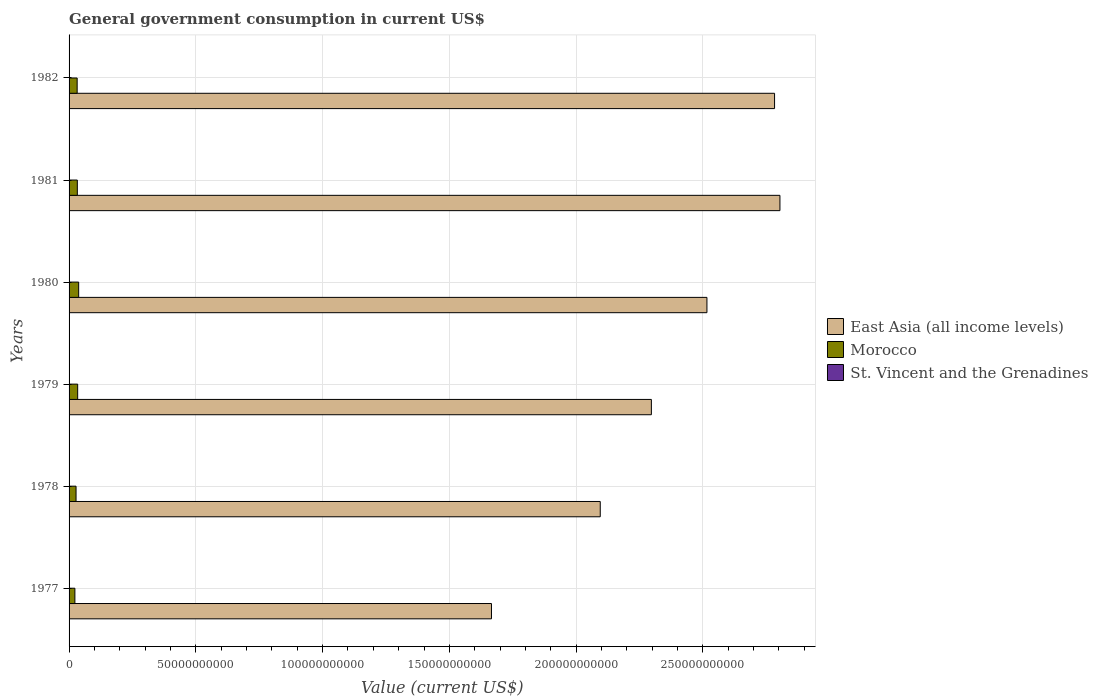How many groups of bars are there?
Offer a terse response. 6. How many bars are there on the 3rd tick from the bottom?
Offer a very short reply. 3. What is the label of the 3rd group of bars from the top?
Offer a very short reply. 1980. What is the government conusmption in East Asia (all income levels) in 1977?
Offer a terse response. 1.67e+11. Across all years, what is the maximum government conusmption in East Asia (all income levels)?
Make the answer very short. 2.80e+11. Across all years, what is the minimum government conusmption in St. Vincent and the Grenadines?
Make the answer very short. 8.13e+06. What is the total government conusmption in Morocco in the graph?
Keep it short and to the point. 1.87e+1. What is the difference between the government conusmption in St. Vincent and the Grenadines in 1977 and that in 1978?
Your response must be concise. -2.10e+06. What is the difference between the government conusmption in St. Vincent and the Grenadines in 1981 and the government conusmption in Morocco in 1979?
Provide a succinct answer. -3.38e+09. What is the average government conusmption in East Asia (all income levels) per year?
Your response must be concise. 2.36e+11. In the year 1980, what is the difference between the government conusmption in East Asia (all income levels) and government conusmption in St. Vincent and the Grenadines?
Provide a succinct answer. 2.52e+11. What is the ratio of the government conusmption in Morocco in 1978 to that in 1981?
Provide a short and direct response. 0.85. What is the difference between the highest and the second highest government conusmption in Morocco?
Your answer should be very brief. 3.96e+08. What is the difference between the highest and the lowest government conusmption in Morocco?
Your answer should be compact. 1.50e+09. In how many years, is the government conusmption in East Asia (all income levels) greater than the average government conusmption in East Asia (all income levels) taken over all years?
Make the answer very short. 3. What does the 1st bar from the top in 1981 represents?
Keep it short and to the point. St. Vincent and the Grenadines. What does the 1st bar from the bottom in 1977 represents?
Offer a terse response. East Asia (all income levels). Is it the case that in every year, the sum of the government conusmption in Morocco and government conusmption in St. Vincent and the Grenadines is greater than the government conusmption in East Asia (all income levels)?
Provide a succinct answer. No. How many bars are there?
Offer a terse response. 18. Are all the bars in the graph horizontal?
Give a very brief answer. Yes. How many years are there in the graph?
Ensure brevity in your answer.  6. Does the graph contain any zero values?
Your response must be concise. No. How many legend labels are there?
Make the answer very short. 3. How are the legend labels stacked?
Keep it short and to the point. Vertical. What is the title of the graph?
Ensure brevity in your answer.  General government consumption in current US$. Does "Zimbabwe" appear as one of the legend labels in the graph?
Your response must be concise. No. What is the label or title of the X-axis?
Make the answer very short. Value (current US$). What is the Value (current US$) of East Asia (all income levels) in 1977?
Provide a succinct answer. 1.67e+11. What is the Value (current US$) in Morocco in 1977?
Provide a short and direct response. 2.29e+09. What is the Value (current US$) of St. Vincent and the Grenadines in 1977?
Your response must be concise. 8.13e+06. What is the Value (current US$) in East Asia (all income levels) in 1978?
Your answer should be very brief. 2.10e+11. What is the Value (current US$) of Morocco in 1978?
Your response must be concise. 2.75e+09. What is the Value (current US$) in St. Vincent and the Grenadines in 1978?
Ensure brevity in your answer.  1.02e+07. What is the Value (current US$) of East Asia (all income levels) in 1979?
Make the answer very short. 2.30e+11. What is the Value (current US$) in Morocco in 1979?
Provide a short and direct response. 3.39e+09. What is the Value (current US$) of St. Vincent and the Grenadines in 1979?
Offer a very short reply. 1.26e+07. What is the Value (current US$) in East Asia (all income levels) in 1980?
Offer a very short reply. 2.52e+11. What is the Value (current US$) in Morocco in 1980?
Your answer should be very brief. 3.79e+09. What is the Value (current US$) of St. Vincent and the Grenadines in 1980?
Make the answer very short. 1.39e+07. What is the Value (current US$) in East Asia (all income levels) in 1981?
Your answer should be compact. 2.80e+11. What is the Value (current US$) in Morocco in 1981?
Ensure brevity in your answer.  3.26e+09. What is the Value (current US$) in St. Vincent and the Grenadines in 1981?
Provide a short and direct response. 1.73e+07. What is the Value (current US$) of East Asia (all income levels) in 1982?
Your response must be concise. 2.78e+11. What is the Value (current US$) in Morocco in 1982?
Your answer should be compact. 3.19e+09. What is the Value (current US$) in St. Vincent and the Grenadines in 1982?
Provide a short and direct response. 2.00e+07. Across all years, what is the maximum Value (current US$) in East Asia (all income levels)?
Give a very brief answer. 2.80e+11. Across all years, what is the maximum Value (current US$) in Morocco?
Provide a succinct answer. 3.79e+09. Across all years, what is the maximum Value (current US$) of St. Vincent and the Grenadines?
Ensure brevity in your answer.  2.00e+07. Across all years, what is the minimum Value (current US$) of East Asia (all income levels)?
Your answer should be very brief. 1.67e+11. Across all years, what is the minimum Value (current US$) in Morocco?
Keep it short and to the point. 2.29e+09. Across all years, what is the minimum Value (current US$) in St. Vincent and the Grenadines?
Ensure brevity in your answer.  8.13e+06. What is the total Value (current US$) in East Asia (all income levels) in the graph?
Give a very brief answer. 1.42e+12. What is the total Value (current US$) in Morocco in the graph?
Your response must be concise. 1.87e+1. What is the total Value (current US$) of St. Vincent and the Grenadines in the graph?
Your response must be concise. 8.22e+07. What is the difference between the Value (current US$) of East Asia (all income levels) in 1977 and that in 1978?
Provide a succinct answer. -4.29e+1. What is the difference between the Value (current US$) of Morocco in 1977 and that in 1978?
Ensure brevity in your answer.  -4.59e+08. What is the difference between the Value (current US$) in St. Vincent and the Grenadines in 1977 and that in 1978?
Your answer should be very brief. -2.10e+06. What is the difference between the Value (current US$) in East Asia (all income levels) in 1977 and that in 1979?
Keep it short and to the point. -6.31e+1. What is the difference between the Value (current US$) in Morocco in 1977 and that in 1979?
Make the answer very short. -1.10e+09. What is the difference between the Value (current US$) of St. Vincent and the Grenadines in 1977 and that in 1979?
Your answer should be very brief. -4.46e+06. What is the difference between the Value (current US$) in East Asia (all income levels) in 1977 and that in 1980?
Keep it short and to the point. -8.50e+1. What is the difference between the Value (current US$) in Morocco in 1977 and that in 1980?
Your answer should be compact. -1.50e+09. What is the difference between the Value (current US$) of St. Vincent and the Grenadines in 1977 and that in 1980?
Give a very brief answer. -5.73e+06. What is the difference between the Value (current US$) in East Asia (all income levels) in 1977 and that in 1981?
Provide a short and direct response. -1.14e+11. What is the difference between the Value (current US$) of Morocco in 1977 and that in 1981?
Make the answer very short. -9.63e+08. What is the difference between the Value (current US$) of St. Vincent and the Grenadines in 1977 and that in 1981?
Your answer should be compact. -9.22e+06. What is the difference between the Value (current US$) of East Asia (all income levels) in 1977 and that in 1982?
Your answer should be very brief. -1.12e+11. What is the difference between the Value (current US$) of Morocco in 1977 and that in 1982?
Provide a short and direct response. -8.98e+08. What is the difference between the Value (current US$) of St. Vincent and the Grenadines in 1977 and that in 1982?
Your answer should be compact. -1.19e+07. What is the difference between the Value (current US$) in East Asia (all income levels) in 1978 and that in 1979?
Make the answer very short. -2.02e+1. What is the difference between the Value (current US$) of Morocco in 1978 and that in 1979?
Offer a very short reply. -6.41e+08. What is the difference between the Value (current US$) of St. Vincent and the Grenadines in 1978 and that in 1979?
Provide a succinct answer. -2.37e+06. What is the difference between the Value (current US$) in East Asia (all income levels) in 1978 and that in 1980?
Ensure brevity in your answer.  -4.21e+1. What is the difference between the Value (current US$) in Morocco in 1978 and that in 1980?
Your answer should be very brief. -1.04e+09. What is the difference between the Value (current US$) of St. Vincent and the Grenadines in 1978 and that in 1980?
Provide a short and direct response. -3.64e+06. What is the difference between the Value (current US$) in East Asia (all income levels) in 1978 and that in 1981?
Offer a very short reply. -7.09e+1. What is the difference between the Value (current US$) in Morocco in 1978 and that in 1981?
Make the answer very short. -5.03e+08. What is the difference between the Value (current US$) in St. Vincent and the Grenadines in 1978 and that in 1981?
Make the answer very short. -7.12e+06. What is the difference between the Value (current US$) in East Asia (all income levels) in 1978 and that in 1982?
Offer a very short reply. -6.88e+1. What is the difference between the Value (current US$) in Morocco in 1978 and that in 1982?
Offer a terse response. -4.39e+08. What is the difference between the Value (current US$) in St. Vincent and the Grenadines in 1978 and that in 1982?
Your answer should be compact. -9.79e+06. What is the difference between the Value (current US$) of East Asia (all income levels) in 1979 and that in 1980?
Provide a short and direct response. -2.19e+1. What is the difference between the Value (current US$) in Morocco in 1979 and that in 1980?
Give a very brief answer. -3.96e+08. What is the difference between the Value (current US$) in St. Vincent and the Grenadines in 1979 and that in 1980?
Keep it short and to the point. -1.27e+06. What is the difference between the Value (current US$) of East Asia (all income levels) in 1979 and that in 1981?
Your response must be concise. -5.07e+1. What is the difference between the Value (current US$) in Morocco in 1979 and that in 1981?
Your answer should be compact. 1.37e+08. What is the difference between the Value (current US$) in St. Vincent and the Grenadines in 1979 and that in 1981?
Offer a very short reply. -4.76e+06. What is the difference between the Value (current US$) in East Asia (all income levels) in 1979 and that in 1982?
Offer a very short reply. -4.86e+1. What is the difference between the Value (current US$) of Morocco in 1979 and that in 1982?
Make the answer very short. 2.02e+08. What is the difference between the Value (current US$) in St. Vincent and the Grenadines in 1979 and that in 1982?
Offer a very short reply. -7.43e+06. What is the difference between the Value (current US$) in East Asia (all income levels) in 1980 and that in 1981?
Your response must be concise. -2.88e+1. What is the difference between the Value (current US$) in Morocco in 1980 and that in 1981?
Ensure brevity in your answer.  5.34e+08. What is the difference between the Value (current US$) in St. Vincent and the Grenadines in 1980 and that in 1981?
Offer a terse response. -3.49e+06. What is the difference between the Value (current US$) of East Asia (all income levels) in 1980 and that in 1982?
Keep it short and to the point. -2.67e+1. What is the difference between the Value (current US$) of Morocco in 1980 and that in 1982?
Provide a short and direct response. 5.98e+08. What is the difference between the Value (current US$) of St. Vincent and the Grenadines in 1980 and that in 1982?
Keep it short and to the point. -6.16e+06. What is the difference between the Value (current US$) of East Asia (all income levels) in 1981 and that in 1982?
Offer a terse response. 2.12e+09. What is the difference between the Value (current US$) of Morocco in 1981 and that in 1982?
Give a very brief answer. 6.49e+07. What is the difference between the Value (current US$) in St. Vincent and the Grenadines in 1981 and that in 1982?
Your response must be concise. -2.67e+06. What is the difference between the Value (current US$) in East Asia (all income levels) in 1977 and the Value (current US$) in Morocco in 1978?
Offer a terse response. 1.64e+11. What is the difference between the Value (current US$) of East Asia (all income levels) in 1977 and the Value (current US$) of St. Vincent and the Grenadines in 1978?
Your answer should be very brief. 1.67e+11. What is the difference between the Value (current US$) in Morocco in 1977 and the Value (current US$) in St. Vincent and the Grenadines in 1978?
Your response must be concise. 2.28e+09. What is the difference between the Value (current US$) in East Asia (all income levels) in 1977 and the Value (current US$) in Morocco in 1979?
Provide a short and direct response. 1.63e+11. What is the difference between the Value (current US$) of East Asia (all income levels) in 1977 and the Value (current US$) of St. Vincent and the Grenadines in 1979?
Offer a very short reply. 1.67e+11. What is the difference between the Value (current US$) of Morocco in 1977 and the Value (current US$) of St. Vincent and the Grenadines in 1979?
Your answer should be compact. 2.28e+09. What is the difference between the Value (current US$) of East Asia (all income levels) in 1977 and the Value (current US$) of Morocco in 1980?
Offer a terse response. 1.63e+11. What is the difference between the Value (current US$) in East Asia (all income levels) in 1977 and the Value (current US$) in St. Vincent and the Grenadines in 1980?
Give a very brief answer. 1.67e+11. What is the difference between the Value (current US$) in Morocco in 1977 and the Value (current US$) in St. Vincent and the Grenadines in 1980?
Ensure brevity in your answer.  2.28e+09. What is the difference between the Value (current US$) in East Asia (all income levels) in 1977 and the Value (current US$) in Morocco in 1981?
Your response must be concise. 1.63e+11. What is the difference between the Value (current US$) in East Asia (all income levels) in 1977 and the Value (current US$) in St. Vincent and the Grenadines in 1981?
Provide a short and direct response. 1.67e+11. What is the difference between the Value (current US$) in Morocco in 1977 and the Value (current US$) in St. Vincent and the Grenadines in 1981?
Provide a short and direct response. 2.28e+09. What is the difference between the Value (current US$) of East Asia (all income levels) in 1977 and the Value (current US$) of Morocco in 1982?
Your response must be concise. 1.63e+11. What is the difference between the Value (current US$) in East Asia (all income levels) in 1977 and the Value (current US$) in St. Vincent and the Grenadines in 1982?
Keep it short and to the point. 1.67e+11. What is the difference between the Value (current US$) of Morocco in 1977 and the Value (current US$) of St. Vincent and the Grenadines in 1982?
Provide a succinct answer. 2.27e+09. What is the difference between the Value (current US$) of East Asia (all income levels) in 1978 and the Value (current US$) of Morocco in 1979?
Make the answer very short. 2.06e+11. What is the difference between the Value (current US$) of East Asia (all income levels) in 1978 and the Value (current US$) of St. Vincent and the Grenadines in 1979?
Make the answer very short. 2.10e+11. What is the difference between the Value (current US$) in Morocco in 1978 and the Value (current US$) in St. Vincent and the Grenadines in 1979?
Give a very brief answer. 2.74e+09. What is the difference between the Value (current US$) of East Asia (all income levels) in 1978 and the Value (current US$) of Morocco in 1980?
Your answer should be compact. 2.06e+11. What is the difference between the Value (current US$) of East Asia (all income levels) in 1978 and the Value (current US$) of St. Vincent and the Grenadines in 1980?
Make the answer very short. 2.10e+11. What is the difference between the Value (current US$) of Morocco in 1978 and the Value (current US$) of St. Vincent and the Grenadines in 1980?
Your answer should be very brief. 2.74e+09. What is the difference between the Value (current US$) in East Asia (all income levels) in 1978 and the Value (current US$) in Morocco in 1981?
Your answer should be compact. 2.06e+11. What is the difference between the Value (current US$) in East Asia (all income levels) in 1978 and the Value (current US$) in St. Vincent and the Grenadines in 1981?
Ensure brevity in your answer.  2.10e+11. What is the difference between the Value (current US$) of Morocco in 1978 and the Value (current US$) of St. Vincent and the Grenadines in 1981?
Your answer should be compact. 2.74e+09. What is the difference between the Value (current US$) of East Asia (all income levels) in 1978 and the Value (current US$) of Morocco in 1982?
Give a very brief answer. 2.06e+11. What is the difference between the Value (current US$) of East Asia (all income levels) in 1978 and the Value (current US$) of St. Vincent and the Grenadines in 1982?
Provide a short and direct response. 2.10e+11. What is the difference between the Value (current US$) of Morocco in 1978 and the Value (current US$) of St. Vincent and the Grenadines in 1982?
Offer a terse response. 2.73e+09. What is the difference between the Value (current US$) of East Asia (all income levels) in 1979 and the Value (current US$) of Morocco in 1980?
Your answer should be very brief. 2.26e+11. What is the difference between the Value (current US$) in East Asia (all income levels) in 1979 and the Value (current US$) in St. Vincent and the Grenadines in 1980?
Your response must be concise. 2.30e+11. What is the difference between the Value (current US$) in Morocco in 1979 and the Value (current US$) in St. Vincent and the Grenadines in 1980?
Offer a terse response. 3.38e+09. What is the difference between the Value (current US$) in East Asia (all income levels) in 1979 and the Value (current US$) in Morocco in 1981?
Offer a terse response. 2.26e+11. What is the difference between the Value (current US$) of East Asia (all income levels) in 1979 and the Value (current US$) of St. Vincent and the Grenadines in 1981?
Keep it short and to the point. 2.30e+11. What is the difference between the Value (current US$) of Morocco in 1979 and the Value (current US$) of St. Vincent and the Grenadines in 1981?
Offer a very short reply. 3.38e+09. What is the difference between the Value (current US$) in East Asia (all income levels) in 1979 and the Value (current US$) in Morocco in 1982?
Ensure brevity in your answer.  2.26e+11. What is the difference between the Value (current US$) of East Asia (all income levels) in 1979 and the Value (current US$) of St. Vincent and the Grenadines in 1982?
Offer a terse response. 2.30e+11. What is the difference between the Value (current US$) of Morocco in 1979 and the Value (current US$) of St. Vincent and the Grenadines in 1982?
Provide a short and direct response. 3.37e+09. What is the difference between the Value (current US$) in East Asia (all income levels) in 1980 and the Value (current US$) in Morocco in 1981?
Ensure brevity in your answer.  2.48e+11. What is the difference between the Value (current US$) of East Asia (all income levels) in 1980 and the Value (current US$) of St. Vincent and the Grenadines in 1981?
Provide a short and direct response. 2.52e+11. What is the difference between the Value (current US$) in Morocco in 1980 and the Value (current US$) in St. Vincent and the Grenadines in 1981?
Give a very brief answer. 3.77e+09. What is the difference between the Value (current US$) in East Asia (all income levels) in 1980 and the Value (current US$) in Morocco in 1982?
Ensure brevity in your answer.  2.48e+11. What is the difference between the Value (current US$) of East Asia (all income levels) in 1980 and the Value (current US$) of St. Vincent and the Grenadines in 1982?
Offer a very short reply. 2.52e+11. What is the difference between the Value (current US$) in Morocco in 1980 and the Value (current US$) in St. Vincent and the Grenadines in 1982?
Your answer should be compact. 3.77e+09. What is the difference between the Value (current US$) in East Asia (all income levels) in 1981 and the Value (current US$) in Morocco in 1982?
Ensure brevity in your answer.  2.77e+11. What is the difference between the Value (current US$) of East Asia (all income levels) in 1981 and the Value (current US$) of St. Vincent and the Grenadines in 1982?
Give a very brief answer. 2.80e+11. What is the difference between the Value (current US$) in Morocco in 1981 and the Value (current US$) in St. Vincent and the Grenadines in 1982?
Give a very brief answer. 3.24e+09. What is the average Value (current US$) of East Asia (all income levels) per year?
Make the answer very short. 2.36e+11. What is the average Value (current US$) of Morocco per year?
Your answer should be very brief. 3.11e+09. What is the average Value (current US$) in St. Vincent and the Grenadines per year?
Keep it short and to the point. 1.37e+07. In the year 1977, what is the difference between the Value (current US$) in East Asia (all income levels) and Value (current US$) in Morocco?
Give a very brief answer. 1.64e+11. In the year 1977, what is the difference between the Value (current US$) of East Asia (all income levels) and Value (current US$) of St. Vincent and the Grenadines?
Your answer should be compact. 1.67e+11. In the year 1977, what is the difference between the Value (current US$) in Morocco and Value (current US$) in St. Vincent and the Grenadines?
Give a very brief answer. 2.29e+09. In the year 1978, what is the difference between the Value (current US$) of East Asia (all income levels) and Value (current US$) of Morocco?
Your answer should be compact. 2.07e+11. In the year 1978, what is the difference between the Value (current US$) in East Asia (all income levels) and Value (current US$) in St. Vincent and the Grenadines?
Give a very brief answer. 2.10e+11. In the year 1978, what is the difference between the Value (current US$) of Morocco and Value (current US$) of St. Vincent and the Grenadines?
Offer a very short reply. 2.74e+09. In the year 1979, what is the difference between the Value (current US$) of East Asia (all income levels) and Value (current US$) of Morocco?
Ensure brevity in your answer.  2.26e+11. In the year 1979, what is the difference between the Value (current US$) in East Asia (all income levels) and Value (current US$) in St. Vincent and the Grenadines?
Ensure brevity in your answer.  2.30e+11. In the year 1979, what is the difference between the Value (current US$) in Morocco and Value (current US$) in St. Vincent and the Grenadines?
Your response must be concise. 3.38e+09. In the year 1980, what is the difference between the Value (current US$) of East Asia (all income levels) and Value (current US$) of Morocco?
Offer a terse response. 2.48e+11. In the year 1980, what is the difference between the Value (current US$) in East Asia (all income levels) and Value (current US$) in St. Vincent and the Grenadines?
Offer a very short reply. 2.52e+11. In the year 1980, what is the difference between the Value (current US$) of Morocco and Value (current US$) of St. Vincent and the Grenadines?
Ensure brevity in your answer.  3.78e+09. In the year 1981, what is the difference between the Value (current US$) in East Asia (all income levels) and Value (current US$) in Morocco?
Your answer should be compact. 2.77e+11. In the year 1981, what is the difference between the Value (current US$) of East Asia (all income levels) and Value (current US$) of St. Vincent and the Grenadines?
Ensure brevity in your answer.  2.80e+11. In the year 1981, what is the difference between the Value (current US$) of Morocco and Value (current US$) of St. Vincent and the Grenadines?
Give a very brief answer. 3.24e+09. In the year 1982, what is the difference between the Value (current US$) of East Asia (all income levels) and Value (current US$) of Morocco?
Offer a very short reply. 2.75e+11. In the year 1982, what is the difference between the Value (current US$) in East Asia (all income levels) and Value (current US$) in St. Vincent and the Grenadines?
Your answer should be compact. 2.78e+11. In the year 1982, what is the difference between the Value (current US$) of Morocco and Value (current US$) of St. Vincent and the Grenadines?
Your answer should be very brief. 3.17e+09. What is the ratio of the Value (current US$) of East Asia (all income levels) in 1977 to that in 1978?
Make the answer very short. 0.8. What is the ratio of the Value (current US$) of Morocco in 1977 to that in 1978?
Your response must be concise. 0.83. What is the ratio of the Value (current US$) of St. Vincent and the Grenadines in 1977 to that in 1978?
Provide a succinct answer. 0.79. What is the ratio of the Value (current US$) in East Asia (all income levels) in 1977 to that in 1979?
Provide a succinct answer. 0.73. What is the ratio of the Value (current US$) in Morocco in 1977 to that in 1979?
Offer a very short reply. 0.68. What is the ratio of the Value (current US$) of St. Vincent and the Grenadines in 1977 to that in 1979?
Ensure brevity in your answer.  0.65. What is the ratio of the Value (current US$) of East Asia (all income levels) in 1977 to that in 1980?
Your answer should be compact. 0.66. What is the ratio of the Value (current US$) of Morocco in 1977 to that in 1980?
Your answer should be very brief. 0.61. What is the ratio of the Value (current US$) in St. Vincent and the Grenadines in 1977 to that in 1980?
Your answer should be compact. 0.59. What is the ratio of the Value (current US$) in East Asia (all income levels) in 1977 to that in 1981?
Your response must be concise. 0.59. What is the ratio of the Value (current US$) in Morocco in 1977 to that in 1981?
Keep it short and to the point. 0.7. What is the ratio of the Value (current US$) in St. Vincent and the Grenadines in 1977 to that in 1981?
Provide a short and direct response. 0.47. What is the ratio of the Value (current US$) of East Asia (all income levels) in 1977 to that in 1982?
Your response must be concise. 0.6. What is the ratio of the Value (current US$) in Morocco in 1977 to that in 1982?
Offer a very short reply. 0.72. What is the ratio of the Value (current US$) of St. Vincent and the Grenadines in 1977 to that in 1982?
Ensure brevity in your answer.  0.41. What is the ratio of the Value (current US$) of East Asia (all income levels) in 1978 to that in 1979?
Your response must be concise. 0.91. What is the ratio of the Value (current US$) in Morocco in 1978 to that in 1979?
Provide a short and direct response. 0.81. What is the ratio of the Value (current US$) of St. Vincent and the Grenadines in 1978 to that in 1979?
Your answer should be very brief. 0.81. What is the ratio of the Value (current US$) of East Asia (all income levels) in 1978 to that in 1980?
Provide a succinct answer. 0.83. What is the ratio of the Value (current US$) in Morocco in 1978 to that in 1980?
Ensure brevity in your answer.  0.73. What is the ratio of the Value (current US$) of St. Vincent and the Grenadines in 1978 to that in 1980?
Ensure brevity in your answer.  0.74. What is the ratio of the Value (current US$) of East Asia (all income levels) in 1978 to that in 1981?
Provide a succinct answer. 0.75. What is the ratio of the Value (current US$) in Morocco in 1978 to that in 1981?
Your answer should be compact. 0.85. What is the ratio of the Value (current US$) in St. Vincent and the Grenadines in 1978 to that in 1981?
Offer a very short reply. 0.59. What is the ratio of the Value (current US$) of East Asia (all income levels) in 1978 to that in 1982?
Ensure brevity in your answer.  0.75. What is the ratio of the Value (current US$) in Morocco in 1978 to that in 1982?
Keep it short and to the point. 0.86. What is the ratio of the Value (current US$) in St. Vincent and the Grenadines in 1978 to that in 1982?
Provide a short and direct response. 0.51. What is the ratio of the Value (current US$) of East Asia (all income levels) in 1979 to that in 1980?
Ensure brevity in your answer.  0.91. What is the ratio of the Value (current US$) in Morocco in 1979 to that in 1980?
Make the answer very short. 0.9. What is the ratio of the Value (current US$) in St. Vincent and the Grenadines in 1979 to that in 1980?
Keep it short and to the point. 0.91. What is the ratio of the Value (current US$) of East Asia (all income levels) in 1979 to that in 1981?
Offer a terse response. 0.82. What is the ratio of the Value (current US$) in Morocco in 1979 to that in 1981?
Your response must be concise. 1.04. What is the ratio of the Value (current US$) in St. Vincent and the Grenadines in 1979 to that in 1981?
Your answer should be very brief. 0.73. What is the ratio of the Value (current US$) of East Asia (all income levels) in 1979 to that in 1982?
Your answer should be very brief. 0.83. What is the ratio of the Value (current US$) in Morocco in 1979 to that in 1982?
Your answer should be compact. 1.06. What is the ratio of the Value (current US$) of St. Vincent and the Grenadines in 1979 to that in 1982?
Your answer should be compact. 0.63. What is the ratio of the Value (current US$) of East Asia (all income levels) in 1980 to that in 1981?
Ensure brevity in your answer.  0.9. What is the ratio of the Value (current US$) of Morocco in 1980 to that in 1981?
Provide a short and direct response. 1.16. What is the ratio of the Value (current US$) of St. Vincent and the Grenadines in 1980 to that in 1981?
Your response must be concise. 0.8. What is the ratio of the Value (current US$) in East Asia (all income levels) in 1980 to that in 1982?
Your answer should be very brief. 0.9. What is the ratio of the Value (current US$) of Morocco in 1980 to that in 1982?
Your answer should be compact. 1.19. What is the ratio of the Value (current US$) in St. Vincent and the Grenadines in 1980 to that in 1982?
Provide a short and direct response. 0.69. What is the ratio of the Value (current US$) of East Asia (all income levels) in 1981 to that in 1982?
Offer a terse response. 1.01. What is the ratio of the Value (current US$) of Morocco in 1981 to that in 1982?
Keep it short and to the point. 1.02. What is the ratio of the Value (current US$) in St. Vincent and the Grenadines in 1981 to that in 1982?
Give a very brief answer. 0.87. What is the difference between the highest and the second highest Value (current US$) of East Asia (all income levels)?
Your response must be concise. 2.12e+09. What is the difference between the highest and the second highest Value (current US$) in Morocco?
Make the answer very short. 3.96e+08. What is the difference between the highest and the second highest Value (current US$) of St. Vincent and the Grenadines?
Your answer should be compact. 2.67e+06. What is the difference between the highest and the lowest Value (current US$) of East Asia (all income levels)?
Provide a short and direct response. 1.14e+11. What is the difference between the highest and the lowest Value (current US$) in Morocco?
Provide a succinct answer. 1.50e+09. What is the difference between the highest and the lowest Value (current US$) in St. Vincent and the Grenadines?
Your response must be concise. 1.19e+07. 